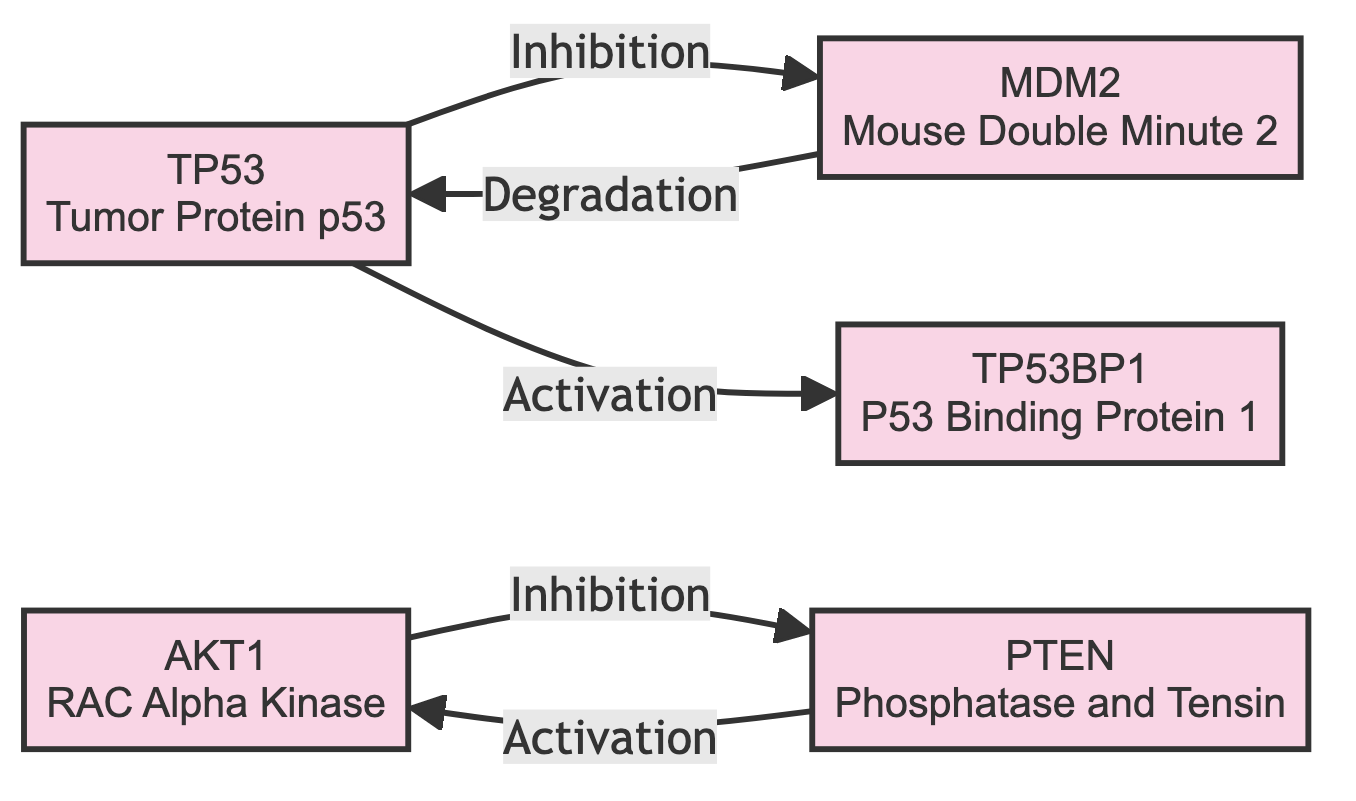What is the total number of proteins (nodes) in the diagram? The diagram lists five unique proteins: TP53, MDM2, AKT1, PTEN, and TP53BP1. By counting these, we determine the total number of proteins is five.
Answer: 5 Which protein is inhibited by TP53? According to the diagram, there is a directed edge from TP53 to MDM2 labeled "Inhibition", indicating that TP53 inhibits MDM2.
Answer: MDM2 What type of interaction exists between AKT1 and PTEN? The diagram shows a directed edge from AKT1 to PTEN labeled "Inhibition" and another directed edge from PTEN to AKT1 labeled "Activation". Thus, the relationships between them are mutual inhibition and activation. However, the direct interaction of interest is "Inhibition".
Answer: Inhibition How many directed edges (interactions) are present in the diagram? The diagram includes a total of five directed edges: TP53 to MDM2, MDM2 to TP53, AKT1 to PTEN, PTEN to AKT1, and TP53 to TP53BP1. Therefore, the total number of directed edges is five.
Answer: 5 Which protein has an activation relationship with TP53? The directed edge from TP53 to TP53BP1 labeled "Activation" indicates that TP53 activates TP53BP1.
Answer: TP53BP1 What is the relationship direction between PTEN and AKT1? The edge from PTEN to AKT1 is labeled "Activation", indicating that PTEN activates AKT1. The relationship direction is from PTEN to AKT1.
Answer: Activation Which protein is regulated by both TP53 and MDM2? MDM2 is regulated by both TP53 (inhibited by TP53) and itself (degradation relationship back to TP53). This indicates a feedback loop involving TP53 and MDM2 but primarily identifies MDM2 as being regulated by TP53.
Answer: MDM2 List the proteins directly activated by TP53. The diagram shows that TP53 activates TP53BP1 through a direct edge. Therefore, TP53 directly activates only one protein.
Answer: TP53BP1 